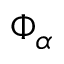<formula> <loc_0><loc_0><loc_500><loc_500>\Phi _ { \alpha }</formula> 